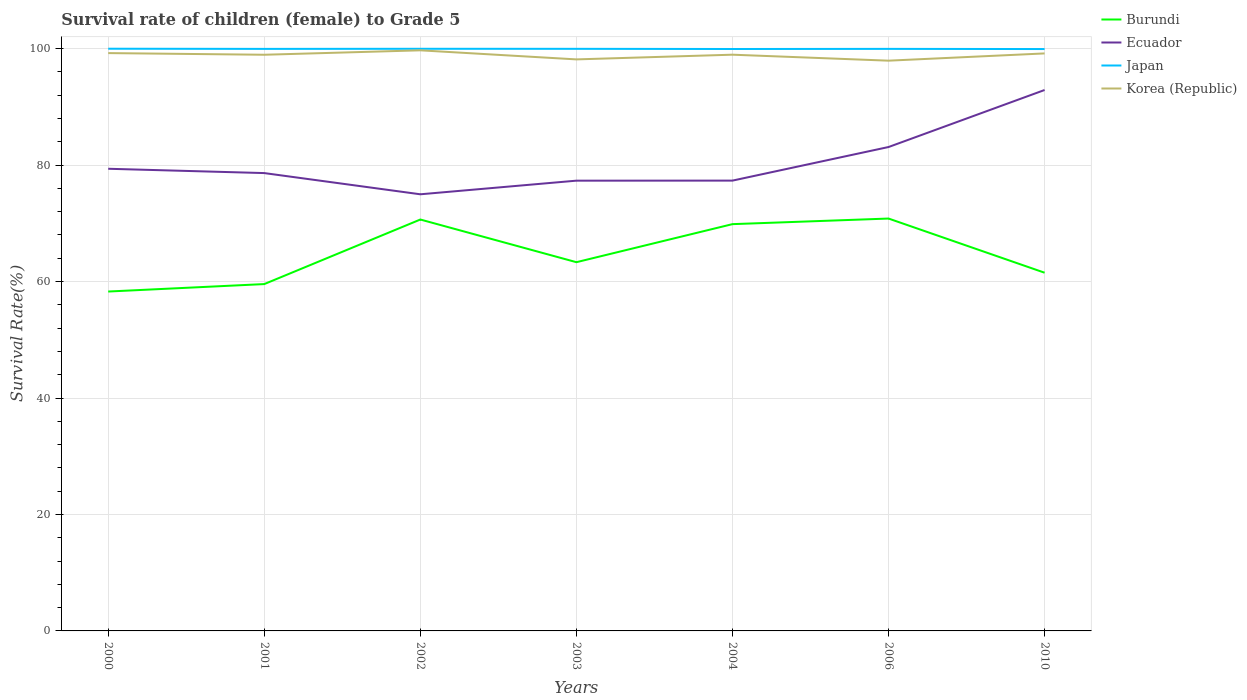How many different coloured lines are there?
Your answer should be very brief. 4. Does the line corresponding to Korea (Republic) intersect with the line corresponding to Ecuador?
Offer a terse response. No. Is the number of lines equal to the number of legend labels?
Offer a very short reply. Yes. Across all years, what is the maximum survival rate of female children to grade 5 in Burundi?
Offer a very short reply. 58.29. In which year was the survival rate of female children to grade 5 in Burundi maximum?
Offer a very short reply. 2000. What is the total survival rate of female children to grade 5 in Burundi in the graph?
Offer a very short reply. -3.23. What is the difference between the highest and the second highest survival rate of female children to grade 5 in Burundi?
Ensure brevity in your answer.  12.53. How many lines are there?
Provide a short and direct response. 4. What is the difference between two consecutive major ticks on the Y-axis?
Give a very brief answer. 20. Are the values on the major ticks of Y-axis written in scientific E-notation?
Offer a very short reply. No. Does the graph contain any zero values?
Provide a succinct answer. No. Does the graph contain grids?
Your answer should be very brief. Yes. What is the title of the graph?
Keep it short and to the point. Survival rate of children (female) to Grade 5. Does "Kyrgyz Republic" appear as one of the legend labels in the graph?
Your answer should be compact. No. What is the label or title of the Y-axis?
Offer a terse response. Survival Rate(%). What is the Survival Rate(%) of Burundi in 2000?
Provide a short and direct response. 58.29. What is the Survival Rate(%) in Ecuador in 2000?
Your answer should be very brief. 79.37. What is the Survival Rate(%) in Japan in 2000?
Make the answer very short. 99.99. What is the Survival Rate(%) of Korea (Republic) in 2000?
Offer a terse response. 99.24. What is the Survival Rate(%) in Burundi in 2001?
Make the answer very short. 59.57. What is the Survival Rate(%) in Ecuador in 2001?
Your response must be concise. 78.63. What is the Survival Rate(%) in Japan in 2001?
Provide a succinct answer. 99.96. What is the Survival Rate(%) of Korea (Republic) in 2001?
Provide a short and direct response. 98.96. What is the Survival Rate(%) in Burundi in 2002?
Offer a terse response. 70.66. What is the Survival Rate(%) in Ecuador in 2002?
Ensure brevity in your answer.  74.99. What is the Survival Rate(%) of Japan in 2002?
Make the answer very short. 99.98. What is the Survival Rate(%) of Korea (Republic) in 2002?
Offer a very short reply. 99.71. What is the Survival Rate(%) in Burundi in 2003?
Offer a terse response. 63.33. What is the Survival Rate(%) in Ecuador in 2003?
Provide a succinct answer. 77.33. What is the Survival Rate(%) in Japan in 2003?
Your response must be concise. 99.97. What is the Survival Rate(%) of Korea (Republic) in 2003?
Provide a succinct answer. 98.16. What is the Survival Rate(%) in Burundi in 2004?
Your answer should be very brief. 69.86. What is the Survival Rate(%) in Ecuador in 2004?
Your response must be concise. 77.34. What is the Survival Rate(%) of Japan in 2004?
Provide a short and direct response. 99.94. What is the Survival Rate(%) of Korea (Republic) in 2004?
Your answer should be compact. 98.97. What is the Survival Rate(%) in Burundi in 2006?
Provide a succinct answer. 70.82. What is the Survival Rate(%) in Ecuador in 2006?
Provide a succinct answer. 83.11. What is the Survival Rate(%) in Japan in 2006?
Offer a terse response. 99.97. What is the Survival Rate(%) in Korea (Republic) in 2006?
Provide a succinct answer. 97.94. What is the Survival Rate(%) in Burundi in 2010?
Make the answer very short. 61.52. What is the Survival Rate(%) in Ecuador in 2010?
Your answer should be compact. 92.9. What is the Survival Rate(%) in Japan in 2010?
Offer a very short reply. 99.94. What is the Survival Rate(%) in Korea (Republic) in 2010?
Give a very brief answer. 99.18. Across all years, what is the maximum Survival Rate(%) of Burundi?
Your answer should be very brief. 70.82. Across all years, what is the maximum Survival Rate(%) in Ecuador?
Your answer should be very brief. 92.9. Across all years, what is the maximum Survival Rate(%) in Japan?
Offer a terse response. 99.99. Across all years, what is the maximum Survival Rate(%) of Korea (Republic)?
Offer a very short reply. 99.71. Across all years, what is the minimum Survival Rate(%) of Burundi?
Ensure brevity in your answer.  58.29. Across all years, what is the minimum Survival Rate(%) of Ecuador?
Offer a very short reply. 74.99. Across all years, what is the minimum Survival Rate(%) of Japan?
Provide a succinct answer. 99.94. Across all years, what is the minimum Survival Rate(%) of Korea (Republic)?
Keep it short and to the point. 97.94. What is the total Survival Rate(%) in Burundi in the graph?
Your answer should be compact. 454.05. What is the total Survival Rate(%) of Ecuador in the graph?
Make the answer very short. 563.68. What is the total Survival Rate(%) of Japan in the graph?
Provide a succinct answer. 699.75. What is the total Survival Rate(%) of Korea (Republic) in the graph?
Your answer should be compact. 692.16. What is the difference between the Survival Rate(%) in Burundi in 2000 and that in 2001?
Provide a short and direct response. -1.28. What is the difference between the Survival Rate(%) in Ecuador in 2000 and that in 2001?
Give a very brief answer. 0.74. What is the difference between the Survival Rate(%) of Japan in 2000 and that in 2001?
Offer a very short reply. 0.03. What is the difference between the Survival Rate(%) of Korea (Republic) in 2000 and that in 2001?
Your response must be concise. 0.28. What is the difference between the Survival Rate(%) in Burundi in 2000 and that in 2002?
Your answer should be very brief. -12.37. What is the difference between the Survival Rate(%) of Ecuador in 2000 and that in 2002?
Make the answer very short. 4.38. What is the difference between the Survival Rate(%) in Japan in 2000 and that in 2002?
Your answer should be very brief. 0.01. What is the difference between the Survival Rate(%) in Korea (Republic) in 2000 and that in 2002?
Give a very brief answer. -0.47. What is the difference between the Survival Rate(%) in Burundi in 2000 and that in 2003?
Offer a terse response. -5.04. What is the difference between the Survival Rate(%) of Ecuador in 2000 and that in 2003?
Offer a terse response. 2.04. What is the difference between the Survival Rate(%) of Japan in 2000 and that in 2003?
Ensure brevity in your answer.  0.02. What is the difference between the Survival Rate(%) in Korea (Republic) in 2000 and that in 2003?
Offer a terse response. 1.08. What is the difference between the Survival Rate(%) of Burundi in 2000 and that in 2004?
Offer a very short reply. -11.57. What is the difference between the Survival Rate(%) in Ecuador in 2000 and that in 2004?
Ensure brevity in your answer.  2.03. What is the difference between the Survival Rate(%) of Japan in 2000 and that in 2004?
Your response must be concise. 0.05. What is the difference between the Survival Rate(%) in Korea (Republic) in 2000 and that in 2004?
Provide a short and direct response. 0.27. What is the difference between the Survival Rate(%) of Burundi in 2000 and that in 2006?
Give a very brief answer. -12.53. What is the difference between the Survival Rate(%) in Ecuador in 2000 and that in 2006?
Offer a terse response. -3.73. What is the difference between the Survival Rate(%) of Japan in 2000 and that in 2006?
Provide a succinct answer. 0.03. What is the difference between the Survival Rate(%) of Korea (Republic) in 2000 and that in 2006?
Ensure brevity in your answer.  1.3. What is the difference between the Survival Rate(%) in Burundi in 2000 and that in 2010?
Ensure brevity in your answer.  -3.23. What is the difference between the Survival Rate(%) of Ecuador in 2000 and that in 2010?
Keep it short and to the point. -13.53. What is the difference between the Survival Rate(%) in Japan in 2000 and that in 2010?
Offer a very short reply. 0.06. What is the difference between the Survival Rate(%) in Korea (Republic) in 2000 and that in 2010?
Ensure brevity in your answer.  0.06. What is the difference between the Survival Rate(%) in Burundi in 2001 and that in 2002?
Your answer should be compact. -11.09. What is the difference between the Survival Rate(%) in Ecuador in 2001 and that in 2002?
Provide a succinct answer. 3.64. What is the difference between the Survival Rate(%) in Japan in 2001 and that in 2002?
Your answer should be compact. -0.02. What is the difference between the Survival Rate(%) in Korea (Republic) in 2001 and that in 2002?
Ensure brevity in your answer.  -0.76. What is the difference between the Survival Rate(%) of Burundi in 2001 and that in 2003?
Make the answer very short. -3.76. What is the difference between the Survival Rate(%) in Ecuador in 2001 and that in 2003?
Offer a terse response. 1.3. What is the difference between the Survival Rate(%) in Japan in 2001 and that in 2003?
Offer a very short reply. -0.01. What is the difference between the Survival Rate(%) in Korea (Republic) in 2001 and that in 2003?
Give a very brief answer. 0.8. What is the difference between the Survival Rate(%) in Burundi in 2001 and that in 2004?
Your response must be concise. -10.29. What is the difference between the Survival Rate(%) in Ecuador in 2001 and that in 2004?
Offer a terse response. 1.29. What is the difference between the Survival Rate(%) of Japan in 2001 and that in 2004?
Provide a succinct answer. 0.02. What is the difference between the Survival Rate(%) of Korea (Republic) in 2001 and that in 2004?
Your response must be concise. -0.01. What is the difference between the Survival Rate(%) of Burundi in 2001 and that in 2006?
Make the answer very short. -11.25. What is the difference between the Survival Rate(%) of Ecuador in 2001 and that in 2006?
Your answer should be very brief. -4.47. What is the difference between the Survival Rate(%) of Japan in 2001 and that in 2006?
Your answer should be compact. -0. What is the difference between the Survival Rate(%) of Korea (Republic) in 2001 and that in 2006?
Offer a very short reply. 1.02. What is the difference between the Survival Rate(%) in Burundi in 2001 and that in 2010?
Keep it short and to the point. -1.95. What is the difference between the Survival Rate(%) of Ecuador in 2001 and that in 2010?
Your answer should be compact. -14.27. What is the difference between the Survival Rate(%) in Japan in 2001 and that in 2010?
Keep it short and to the point. 0.03. What is the difference between the Survival Rate(%) in Korea (Republic) in 2001 and that in 2010?
Keep it short and to the point. -0.23. What is the difference between the Survival Rate(%) of Burundi in 2002 and that in 2003?
Offer a terse response. 7.33. What is the difference between the Survival Rate(%) of Ecuador in 2002 and that in 2003?
Offer a terse response. -2.34. What is the difference between the Survival Rate(%) in Japan in 2002 and that in 2003?
Provide a short and direct response. 0.01. What is the difference between the Survival Rate(%) in Korea (Republic) in 2002 and that in 2003?
Your answer should be compact. 1.56. What is the difference between the Survival Rate(%) in Burundi in 2002 and that in 2004?
Keep it short and to the point. 0.79. What is the difference between the Survival Rate(%) in Ecuador in 2002 and that in 2004?
Your response must be concise. -2.35. What is the difference between the Survival Rate(%) in Japan in 2002 and that in 2004?
Your answer should be compact. 0.04. What is the difference between the Survival Rate(%) of Korea (Republic) in 2002 and that in 2004?
Give a very brief answer. 0.75. What is the difference between the Survival Rate(%) of Burundi in 2002 and that in 2006?
Make the answer very short. -0.17. What is the difference between the Survival Rate(%) of Ecuador in 2002 and that in 2006?
Offer a very short reply. -8.12. What is the difference between the Survival Rate(%) in Japan in 2002 and that in 2006?
Make the answer very short. 0.01. What is the difference between the Survival Rate(%) of Korea (Republic) in 2002 and that in 2006?
Your answer should be compact. 1.78. What is the difference between the Survival Rate(%) of Burundi in 2002 and that in 2010?
Ensure brevity in your answer.  9.14. What is the difference between the Survival Rate(%) of Ecuador in 2002 and that in 2010?
Your answer should be very brief. -17.91. What is the difference between the Survival Rate(%) of Japan in 2002 and that in 2010?
Your response must be concise. 0.04. What is the difference between the Survival Rate(%) of Korea (Republic) in 2002 and that in 2010?
Offer a terse response. 0.53. What is the difference between the Survival Rate(%) of Burundi in 2003 and that in 2004?
Give a very brief answer. -6.54. What is the difference between the Survival Rate(%) in Ecuador in 2003 and that in 2004?
Keep it short and to the point. -0.01. What is the difference between the Survival Rate(%) in Japan in 2003 and that in 2004?
Your response must be concise. 0.03. What is the difference between the Survival Rate(%) in Korea (Republic) in 2003 and that in 2004?
Make the answer very short. -0.81. What is the difference between the Survival Rate(%) of Burundi in 2003 and that in 2006?
Provide a short and direct response. -7.5. What is the difference between the Survival Rate(%) in Ecuador in 2003 and that in 2006?
Provide a short and direct response. -5.78. What is the difference between the Survival Rate(%) in Japan in 2003 and that in 2006?
Give a very brief answer. 0.01. What is the difference between the Survival Rate(%) of Korea (Republic) in 2003 and that in 2006?
Ensure brevity in your answer.  0.22. What is the difference between the Survival Rate(%) of Burundi in 2003 and that in 2010?
Keep it short and to the point. 1.81. What is the difference between the Survival Rate(%) in Ecuador in 2003 and that in 2010?
Offer a terse response. -15.57. What is the difference between the Survival Rate(%) of Japan in 2003 and that in 2010?
Your answer should be very brief. 0.04. What is the difference between the Survival Rate(%) in Korea (Republic) in 2003 and that in 2010?
Your answer should be very brief. -1.02. What is the difference between the Survival Rate(%) of Burundi in 2004 and that in 2006?
Your answer should be compact. -0.96. What is the difference between the Survival Rate(%) of Ecuador in 2004 and that in 2006?
Ensure brevity in your answer.  -5.77. What is the difference between the Survival Rate(%) in Japan in 2004 and that in 2006?
Make the answer very short. -0.02. What is the difference between the Survival Rate(%) of Korea (Republic) in 2004 and that in 2006?
Your response must be concise. 1.03. What is the difference between the Survival Rate(%) in Burundi in 2004 and that in 2010?
Your answer should be compact. 8.34. What is the difference between the Survival Rate(%) in Ecuador in 2004 and that in 2010?
Make the answer very short. -15.56. What is the difference between the Survival Rate(%) of Japan in 2004 and that in 2010?
Make the answer very short. 0.01. What is the difference between the Survival Rate(%) of Korea (Republic) in 2004 and that in 2010?
Your answer should be very brief. -0.22. What is the difference between the Survival Rate(%) of Burundi in 2006 and that in 2010?
Your answer should be very brief. 9.3. What is the difference between the Survival Rate(%) in Ecuador in 2006 and that in 2010?
Provide a succinct answer. -9.8. What is the difference between the Survival Rate(%) in Japan in 2006 and that in 2010?
Ensure brevity in your answer.  0.03. What is the difference between the Survival Rate(%) of Korea (Republic) in 2006 and that in 2010?
Give a very brief answer. -1.24. What is the difference between the Survival Rate(%) in Burundi in 2000 and the Survival Rate(%) in Ecuador in 2001?
Provide a short and direct response. -20.34. What is the difference between the Survival Rate(%) of Burundi in 2000 and the Survival Rate(%) of Japan in 2001?
Your answer should be compact. -41.67. What is the difference between the Survival Rate(%) of Burundi in 2000 and the Survival Rate(%) of Korea (Republic) in 2001?
Ensure brevity in your answer.  -40.67. What is the difference between the Survival Rate(%) in Ecuador in 2000 and the Survival Rate(%) in Japan in 2001?
Give a very brief answer. -20.59. What is the difference between the Survival Rate(%) in Ecuador in 2000 and the Survival Rate(%) in Korea (Republic) in 2001?
Provide a succinct answer. -19.58. What is the difference between the Survival Rate(%) of Japan in 2000 and the Survival Rate(%) of Korea (Republic) in 2001?
Offer a terse response. 1.04. What is the difference between the Survival Rate(%) of Burundi in 2000 and the Survival Rate(%) of Ecuador in 2002?
Provide a succinct answer. -16.7. What is the difference between the Survival Rate(%) in Burundi in 2000 and the Survival Rate(%) in Japan in 2002?
Your response must be concise. -41.69. What is the difference between the Survival Rate(%) of Burundi in 2000 and the Survival Rate(%) of Korea (Republic) in 2002?
Offer a very short reply. -41.43. What is the difference between the Survival Rate(%) of Ecuador in 2000 and the Survival Rate(%) of Japan in 2002?
Ensure brevity in your answer.  -20.61. What is the difference between the Survival Rate(%) of Ecuador in 2000 and the Survival Rate(%) of Korea (Republic) in 2002?
Offer a very short reply. -20.34. What is the difference between the Survival Rate(%) in Japan in 2000 and the Survival Rate(%) in Korea (Republic) in 2002?
Give a very brief answer. 0.28. What is the difference between the Survival Rate(%) of Burundi in 2000 and the Survival Rate(%) of Ecuador in 2003?
Provide a short and direct response. -19.04. What is the difference between the Survival Rate(%) of Burundi in 2000 and the Survival Rate(%) of Japan in 2003?
Provide a short and direct response. -41.68. What is the difference between the Survival Rate(%) in Burundi in 2000 and the Survival Rate(%) in Korea (Republic) in 2003?
Ensure brevity in your answer.  -39.87. What is the difference between the Survival Rate(%) of Ecuador in 2000 and the Survival Rate(%) of Japan in 2003?
Offer a terse response. -20.6. What is the difference between the Survival Rate(%) in Ecuador in 2000 and the Survival Rate(%) in Korea (Republic) in 2003?
Your answer should be compact. -18.79. What is the difference between the Survival Rate(%) in Japan in 2000 and the Survival Rate(%) in Korea (Republic) in 2003?
Your answer should be compact. 1.83. What is the difference between the Survival Rate(%) of Burundi in 2000 and the Survival Rate(%) of Ecuador in 2004?
Your response must be concise. -19.05. What is the difference between the Survival Rate(%) of Burundi in 2000 and the Survival Rate(%) of Japan in 2004?
Give a very brief answer. -41.65. What is the difference between the Survival Rate(%) in Burundi in 2000 and the Survival Rate(%) in Korea (Republic) in 2004?
Make the answer very short. -40.68. What is the difference between the Survival Rate(%) of Ecuador in 2000 and the Survival Rate(%) of Japan in 2004?
Your answer should be compact. -20.57. What is the difference between the Survival Rate(%) in Ecuador in 2000 and the Survival Rate(%) in Korea (Republic) in 2004?
Offer a terse response. -19.59. What is the difference between the Survival Rate(%) of Japan in 2000 and the Survival Rate(%) of Korea (Republic) in 2004?
Provide a succinct answer. 1.03. What is the difference between the Survival Rate(%) in Burundi in 2000 and the Survival Rate(%) in Ecuador in 2006?
Give a very brief answer. -24.82. What is the difference between the Survival Rate(%) of Burundi in 2000 and the Survival Rate(%) of Japan in 2006?
Ensure brevity in your answer.  -41.68. What is the difference between the Survival Rate(%) in Burundi in 2000 and the Survival Rate(%) in Korea (Republic) in 2006?
Keep it short and to the point. -39.65. What is the difference between the Survival Rate(%) in Ecuador in 2000 and the Survival Rate(%) in Japan in 2006?
Ensure brevity in your answer.  -20.59. What is the difference between the Survival Rate(%) in Ecuador in 2000 and the Survival Rate(%) in Korea (Republic) in 2006?
Offer a terse response. -18.57. What is the difference between the Survival Rate(%) of Japan in 2000 and the Survival Rate(%) of Korea (Republic) in 2006?
Keep it short and to the point. 2.05. What is the difference between the Survival Rate(%) of Burundi in 2000 and the Survival Rate(%) of Ecuador in 2010?
Offer a very short reply. -34.61. What is the difference between the Survival Rate(%) of Burundi in 2000 and the Survival Rate(%) of Japan in 2010?
Your response must be concise. -41.65. What is the difference between the Survival Rate(%) in Burundi in 2000 and the Survival Rate(%) in Korea (Republic) in 2010?
Keep it short and to the point. -40.89. What is the difference between the Survival Rate(%) of Ecuador in 2000 and the Survival Rate(%) of Japan in 2010?
Your answer should be compact. -20.56. What is the difference between the Survival Rate(%) in Ecuador in 2000 and the Survival Rate(%) in Korea (Republic) in 2010?
Provide a succinct answer. -19.81. What is the difference between the Survival Rate(%) in Japan in 2000 and the Survival Rate(%) in Korea (Republic) in 2010?
Your response must be concise. 0.81. What is the difference between the Survival Rate(%) of Burundi in 2001 and the Survival Rate(%) of Ecuador in 2002?
Your answer should be compact. -15.42. What is the difference between the Survival Rate(%) of Burundi in 2001 and the Survival Rate(%) of Japan in 2002?
Ensure brevity in your answer.  -40.41. What is the difference between the Survival Rate(%) in Burundi in 2001 and the Survival Rate(%) in Korea (Republic) in 2002?
Offer a terse response. -40.14. What is the difference between the Survival Rate(%) in Ecuador in 2001 and the Survival Rate(%) in Japan in 2002?
Provide a short and direct response. -21.35. What is the difference between the Survival Rate(%) in Ecuador in 2001 and the Survival Rate(%) in Korea (Republic) in 2002?
Your answer should be very brief. -21.08. What is the difference between the Survival Rate(%) in Japan in 2001 and the Survival Rate(%) in Korea (Republic) in 2002?
Give a very brief answer. 0.25. What is the difference between the Survival Rate(%) in Burundi in 2001 and the Survival Rate(%) in Ecuador in 2003?
Offer a very short reply. -17.76. What is the difference between the Survival Rate(%) in Burundi in 2001 and the Survival Rate(%) in Japan in 2003?
Your answer should be compact. -40.4. What is the difference between the Survival Rate(%) in Burundi in 2001 and the Survival Rate(%) in Korea (Republic) in 2003?
Offer a terse response. -38.59. What is the difference between the Survival Rate(%) in Ecuador in 2001 and the Survival Rate(%) in Japan in 2003?
Give a very brief answer. -21.34. What is the difference between the Survival Rate(%) of Ecuador in 2001 and the Survival Rate(%) of Korea (Republic) in 2003?
Your answer should be compact. -19.53. What is the difference between the Survival Rate(%) of Japan in 2001 and the Survival Rate(%) of Korea (Republic) in 2003?
Provide a succinct answer. 1.8. What is the difference between the Survival Rate(%) in Burundi in 2001 and the Survival Rate(%) in Ecuador in 2004?
Your answer should be compact. -17.77. What is the difference between the Survival Rate(%) in Burundi in 2001 and the Survival Rate(%) in Japan in 2004?
Offer a terse response. -40.37. What is the difference between the Survival Rate(%) of Burundi in 2001 and the Survival Rate(%) of Korea (Republic) in 2004?
Your answer should be very brief. -39.4. What is the difference between the Survival Rate(%) in Ecuador in 2001 and the Survival Rate(%) in Japan in 2004?
Ensure brevity in your answer.  -21.31. What is the difference between the Survival Rate(%) in Ecuador in 2001 and the Survival Rate(%) in Korea (Republic) in 2004?
Keep it short and to the point. -20.33. What is the difference between the Survival Rate(%) in Japan in 2001 and the Survival Rate(%) in Korea (Republic) in 2004?
Keep it short and to the point. 1. What is the difference between the Survival Rate(%) in Burundi in 2001 and the Survival Rate(%) in Ecuador in 2006?
Provide a succinct answer. -23.54. What is the difference between the Survival Rate(%) of Burundi in 2001 and the Survival Rate(%) of Japan in 2006?
Your response must be concise. -40.4. What is the difference between the Survival Rate(%) in Burundi in 2001 and the Survival Rate(%) in Korea (Republic) in 2006?
Provide a succinct answer. -38.37. What is the difference between the Survival Rate(%) in Ecuador in 2001 and the Survival Rate(%) in Japan in 2006?
Your response must be concise. -21.33. What is the difference between the Survival Rate(%) in Ecuador in 2001 and the Survival Rate(%) in Korea (Republic) in 2006?
Your response must be concise. -19.31. What is the difference between the Survival Rate(%) of Japan in 2001 and the Survival Rate(%) of Korea (Republic) in 2006?
Give a very brief answer. 2.02. What is the difference between the Survival Rate(%) of Burundi in 2001 and the Survival Rate(%) of Ecuador in 2010?
Make the answer very short. -33.33. What is the difference between the Survival Rate(%) of Burundi in 2001 and the Survival Rate(%) of Japan in 2010?
Ensure brevity in your answer.  -40.37. What is the difference between the Survival Rate(%) of Burundi in 2001 and the Survival Rate(%) of Korea (Republic) in 2010?
Offer a terse response. -39.61. What is the difference between the Survival Rate(%) of Ecuador in 2001 and the Survival Rate(%) of Japan in 2010?
Make the answer very short. -21.3. What is the difference between the Survival Rate(%) of Ecuador in 2001 and the Survival Rate(%) of Korea (Republic) in 2010?
Your response must be concise. -20.55. What is the difference between the Survival Rate(%) of Japan in 2001 and the Survival Rate(%) of Korea (Republic) in 2010?
Make the answer very short. 0.78. What is the difference between the Survival Rate(%) in Burundi in 2002 and the Survival Rate(%) in Ecuador in 2003?
Make the answer very short. -6.67. What is the difference between the Survival Rate(%) in Burundi in 2002 and the Survival Rate(%) in Japan in 2003?
Give a very brief answer. -29.32. What is the difference between the Survival Rate(%) in Burundi in 2002 and the Survival Rate(%) in Korea (Republic) in 2003?
Offer a terse response. -27.5. What is the difference between the Survival Rate(%) in Ecuador in 2002 and the Survival Rate(%) in Japan in 2003?
Offer a terse response. -24.98. What is the difference between the Survival Rate(%) in Ecuador in 2002 and the Survival Rate(%) in Korea (Republic) in 2003?
Offer a very short reply. -23.17. What is the difference between the Survival Rate(%) of Japan in 2002 and the Survival Rate(%) of Korea (Republic) in 2003?
Offer a very short reply. 1.82. What is the difference between the Survival Rate(%) in Burundi in 2002 and the Survival Rate(%) in Ecuador in 2004?
Make the answer very short. -6.68. What is the difference between the Survival Rate(%) of Burundi in 2002 and the Survival Rate(%) of Japan in 2004?
Your answer should be compact. -29.29. What is the difference between the Survival Rate(%) in Burundi in 2002 and the Survival Rate(%) in Korea (Republic) in 2004?
Provide a succinct answer. -28.31. What is the difference between the Survival Rate(%) of Ecuador in 2002 and the Survival Rate(%) of Japan in 2004?
Give a very brief answer. -24.95. What is the difference between the Survival Rate(%) in Ecuador in 2002 and the Survival Rate(%) in Korea (Republic) in 2004?
Provide a succinct answer. -23.98. What is the difference between the Survival Rate(%) of Burundi in 2002 and the Survival Rate(%) of Ecuador in 2006?
Give a very brief answer. -12.45. What is the difference between the Survival Rate(%) of Burundi in 2002 and the Survival Rate(%) of Japan in 2006?
Provide a short and direct response. -29.31. What is the difference between the Survival Rate(%) in Burundi in 2002 and the Survival Rate(%) in Korea (Republic) in 2006?
Offer a terse response. -27.28. What is the difference between the Survival Rate(%) of Ecuador in 2002 and the Survival Rate(%) of Japan in 2006?
Provide a succinct answer. -24.97. What is the difference between the Survival Rate(%) in Ecuador in 2002 and the Survival Rate(%) in Korea (Republic) in 2006?
Give a very brief answer. -22.95. What is the difference between the Survival Rate(%) in Japan in 2002 and the Survival Rate(%) in Korea (Republic) in 2006?
Keep it short and to the point. 2.04. What is the difference between the Survival Rate(%) in Burundi in 2002 and the Survival Rate(%) in Ecuador in 2010?
Give a very brief answer. -22.25. What is the difference between the Survival Rate(%) of Burundi in 2002 and the Survival Rate(%) of Japan in 2010?
Offer a very short reply. -29.28. What is the difference between the Survival Rate(%) in Burundi in 2002 and the Survival Rate(%) in Korea (Republic) in 2010?
Your answer should be very brief. -28.53. What is the difference between the Survival Rate(%) in Ecuador in 2002 and the Survival Rate(%) in Japan in 2010?
Offer a very short reply. -24.95. What is the difference between the Survival Rate(%) in Ecuador in 2002 and the Survival Rate(%) in Korea (Republic) in 2010?
Offer a terse response. -24.19. What is the difference between the Survival Rate(%) in Japan in 2002 and the Survival Rate(%) in Korea (Republic) in 2010?
Make the answer very short. 0.8. What is the difference between the Survival Rate(%) in Burundi in 2003 and the Survival Rate(%) in Ecuador in 2004?
Make the answer very short. -14.01. What is the difference between the Survival Rate(%) of Burundi in 2003 and the Survival Rate(%) of Japan in 2004?
Your answer should be compact. -36.61. What is the difference between the Survival Rate(%) in Burundi in 2003 and the Survival Rate(%) in Korea (Republic) in 2004?
Provide a succinct answer. -35.64. What is the difference between the Survival Rate(%) in Ecuador in 2003 and the Survival Rate(%) in Japan in 2004?
Your response must be concise. -22.61. What is the difference between the Survival Rate(%) in Ecuador in 2003 and the Survival Rate(%) in Korea (Republic) in 2004?
Your response must be concise. -21.64. What is the difference between the Survival Rate(%) in Japan in 2003 and the Survival Rate(%) in Korea (Republic) in 2004?
Offer a terse response. 1.01. What is the difference between the Survival Rate(%) of Burundi in 2003 and the Survival Rate(%) of Ecuador in 2006?
Offer a terse response. -19.78. What is the difference between the Survival Rate(%) in Burundi in 2003 and the Survival Rate(%) in Japan in 2006?
Provide a short and direct response. -36.64. What is the difference between the Survival Rate(%) of Burundi in 2003 and the Survival Rate(%) of Korea (Republic) in 2006?
Offer a very short reply. -34.61. What is the difference between the Survival Rate(%) in Ecuador in 2003 and the Survival Rate(%) in Japan in 2006?
Provide a short and direct response. -22.64. What is the difference between the Survival Rate(%) in Ecuador in 2003 and the Survival Rate(%) in Korea (Republic) in 2006?
Your answer should be very brief. -20.61. What is the difference between the Survival Rate(%) in Japan in 2003 and the Survival Rate(%) in Korea (Republic) in 2006?
Keep it short and to the point. 2.03. What is the difference between the Survival Rate(%) in Burundi in 2003 and the Survival Rate(%) in Ecuador in 2010?
Make the answer very short. -29.57. What is the difference between the Survival Rate(%) of Burundi in 2003 and the Survival Rate(%) of Japan in 2010?
Make the answer very short. -36.61. What is the difference between the Survival Rate(%) of Burundi in 2003 and the Survival Rate(%) of Korea (Republic) in 2010?
Ensure brevity in your answer.  -35.86. What is the difference between the Survival Rate(%) of Ecuador in 2003 and the Survival Rate(%) of Japan in 2010?
Your response must be concise. -22.61. What is the difference between the Survival Rate(%) in Ecuador in 2003 and the Survival Rate(%) in Korea (Republic) in 2010?
Ensure brevity in your answer.  -21.85. What is the difference between the Survival Rate(%) in Japan in 2003 and the Survival Rate(%) in Korea (Republic) in 2010?
Offer a terse response. 0.79. What is the difference between the Survival Rate(%) of Burundi in 2004 and the Survival Rate(%) of Ecuador in 2006?
Offer a terse response. -13.24. What is the difference between the Survival Rate(%) of Burundi in 2004 and the Survival Rate(%) of Japan in 2006?
Make the answer very short. -30.1. What is the difference between the Survival Rate(%) of Burundi in 2004 and the Survival Rate(%) of Korea (Republic) in 2006?
Your answer should be very brief. -28.08. What is the difference between the Survival Rate(%) in Ecuador in 2004 and the Survival Rate(%) in Japan in 2006?
Keep it short and to the point. -22.63. What is the difference between the Survival Rate(%) of Ecuador in 2004 and the Survival Rate(%) of Korea (Republic) in 2006?
Provide a short and direct response. -20.6. What is the difference between the Survival Rate(%) of Japan in 2004 and the Survival Rate(%) of Korea (Republic) in 2006?
Provide a succinct answer. 2. What is the difference between the Survival Rate(%) in Burundi in 2004 and the Survival Rate(%) in Ecuador in 2010?
Make the answer very short. -23.04. What is the difference between the Survival Rate(%) in Burundi in 2004 and the Survival Rate(%) in Japan in 2010?
Offer a very short reply. -30.07. What is the difference between the Survival Rate(%) of Burundi in 2004 and the Survival Rate(%) of Korea (Republic) in 2010?
Make the answer very short. -29.32. What is the difference between the Survival Rate(%) of Ecuador in 2004 and the Survival Rate(%) of Japan in 2010?
Keep it short and to the point. -22.6. What is the difference between the Survival Rate(%) in Ecuador in 2004 and the Survival Rate(%) in Korea (Republic) in 2010?
Provide a succinct answer. -21.84. What is the difference between the Survival Rate(%) in Japan in 2004 and the Survival Rate(%) in Korea (Republic) in 2010?
Provide a succinct answer. 0.76. What is the difference between the Survival Rate(%) in Burundi in 2006 and the Survival Rate(%) in Ecuador in 2010?
Your response must be concise. -22.08. What is the difference between the Survival Rate(%) of Burundi in 2006 and the Survival Rate(%) of Japan in 2010?
Keep it short and to the point. -29.11. What is the difference between the Survival Rate(%) of Burundi in 2006 and the Survival Rate(%) of Korea (Republic) in 2010?
Your answer should be compact. -28.36. What is the difference between the Survival Rate(%) in Ecuador in 2006 and the Survival Rate(%) in Japan in 2010?
Your answer should be very brief. -16.83. What is the difference between the Survival Rate(%) in Ecuador in 2006 and the Survival Rate(%) in Korea (Republic) in 2010?
Give a very brief answer. -16.08. What is the difference between the Survival Rate(%) in Japan in 2006 and the Survival Rate(%) in Korea (Republic) in 2010?
Make the answer very short. 0.78. What is the average Survival Rate(%) of Burundi per year?
Provide a short and direct response. 64.86. What is the average Survival Rate(%) of Ecuador per year?
Keep it short and to the point. 80.53. What is the average Survival Rate(%) of Japan per year?
Provide a short and direct response. 99.96. What is the average Survival Rate(%) in Korea (Republic) per year?
Offer a terse response. 98.88. In the year 2000, what is the difference between the Survival Rate(%) in Burundi and Survival Rate(%) in Ecuador?
Keep it short and to the point. -21.08. In the year 2000, what is the difference between the Survival Rate(%) of Burundi and Survival Rate(%) of Japan?
Offer a terse response. -41.7. In the year 2000, what is the difference between the Survival Rate(%) in Burundi and Survival Rate(%) in Korea (Republic)?
Ensure brevity in your answer.  -40.95. In the year 2000, what is the difference between the Survival Rate(%) in Ecuador and Survival Rate(%) in Japan?
Your answer should be compact. -20.62. In the year 2000, what is the difference between the Survival Rate(%) of Ecuador and Survival Rate(%) of Korea (Republic)?
Your response must be concise. -19.87. In the year 2000, what is the difference between the Survival Rate(%) in Japan and Survival Rate(%) in Korea (Republic)?
Your response must be concise. 0.75. In the year 2001, what is the difference between the Survival Rate(%) in Burundi and Survival Rate(%) in Ecuador?
Provide a short and direct response. -19.06. In the year 2001, what is the difference between the Survival Rate(%) in Burundi and Survival Rate(%) in Japan?
Provide a short and direct response. -40.39. In the year 2001, what is the difference between the Survival Rate(%) of Burundi and Survival Rate(%) of Korea (Republic)?
Provide a short and direct response. -39.39. In the year 2001, what is the difference between the Survival Rate(%) in Ecuador and Survival Rate(%) in Japan?
Ensure brevity in your answer.  -21.33. In the year 2001, what is the difference between the Survival Rate(%) of Ecuador and Survival Rate(%) of Korea (Republic)?
Ensure brevity in your answer.  -20.32. In the year 2001, what is the difference between the Survival Rate(%) of Japan and Survival Rate(%) of Korea (Republic)?
Ensure brevity in your answer.  1.01. In the year 2002, what is the difference between the Survival Rate(%) in Burundi and Survival Rate(%) in Ecuador?
Ensure brevity in your answer.  -4.33. In the year 2002, what is the difference between the Survival Rate(%) of Burundi and Survival Rate(%) of Japan?
Your response must be concise. -29.32. In the year 2002, what is the difference between the Survival Rate(%) in Burundi and Survival Rate(%) in Korea (Republic)?
Give a very brief answer. -29.06. In the year 2002, what is the difference between the Survival Rate(%) in Ecuador and Survival Rate(%) in Japan?
Provide a short and direct response. -24.99. In the year 2002, what is the difference between the Survival Rate(%) of Ecuador and Survival Rate(%) of Korea (Republic)?
Make the answer very short. -24.72. In the year 2002, what is the difference between the Survival Rate(%) of Japan and Survival Rate(%) of Korea (Republic)?
Provide a succinct answer. 0.27. In the year 2003, what is the difference between the Survival Rate(%) in Burundi and Survival Rate(%) in Ecuador?
Offer a very short reply. -14. In the year 2003, what is the difference between the Survival Rate(%) in Burundi and Survival Rate(%) in Japan?
Offer a very short reply. -36.65. In the year 2003, what is the difference between the Survival Rate(%) in Burundi and Survival Rate(%) in Korea (Republic)?
Your answer should be very brief. -34.83. In the year 2003, what is the difference between the Survival Rate(%) in Ecuador and Survival Rate(%) in Japan?
Keep it short and to the point. -22.64. In the year 2003, what is the difference between the Survival Rate(%) of Ecuador and Survival Rate(%) of Korea (Republic)?
Your response must be concise. -20.83. In the year 2003, what is the difference between the Survival Rate(%) in Japan and Survival Rate(%) in Korea (Republic)?
Keep it short and to the point. 1.81. In the year 2004, what is the difference between the Survival Rate(%) in Burundi and Survival Rate(%) in Ecuador?
Your answer should be compact. -7.48. In the year 2004, what is the difference between the Survival Rate(%) of Burundi and Survival Rate(%) of Japan?
Give a very brief answer. -30.08. In the year 2004, what is the difference between the Survival Rate(%) in Burundi and Survival Rate(%) in Korea (Republic)?
Keep it short and to the point. -29.1. In the year 2004, what is the difference between the Survival Rate(%) in Ecuador and Survival Rate(%) in Japan?
Give a very brief answer. -22.6. In the year 2004, what is the difference between the Survival Rate(%) of Ecuador and Survival Rate(%) of Korea (Republic)?
Make the answer very short. -21.63. In the year 2004, what is the difference between the Survival Rate(%) of Japan and Survival Rate(%) of Korea (Republic)?
Offer a very short reply. 0.98. In the year 2006, what is the difference between the Survival Rate(%) in Burundi and Survival Rate(%) in Ecuador?
Your response must be concise. -12.28. In the year 2006, what is the difference between the Survival Rate(%) in Burundi and Survival Rate(%) in Japan?
Offer a very short reply. -29.14. In the year 2006, what is the difference between the Survival Rate(%) in Burundi and Survival Rate(%) in Korea (Republic)?
Provide a succinct answer. -27.12. In the year 2006, what is the difference between the Survival Rate(%) of Ecuador and Survival Rate(%) of Japan?
Ensure brevity in your answer.  -16.86. In the year 2006, what is the difference between the Survival Rate(%) in Ecuador and Survival Rate(%) in Korea (Republic)?
Your response must be concise. -14.83. In the year 2006, what is the difference between the Survival Rate(%) in Japan and Survival Rate(%) in Korea (Republic)?
Offer a terse response. 2.03. In the year 2010, what is the difference between the Survival Rate(%) of Burundi and Survival Rate(%) of Ecuador?
Make the answer very short. -31.38. In the year 2010, what is the difference between the Survival Rate(%) of Burundi and Survival Rate(%) of Japan?
Give a very brief answer. -38.41. In the year 2010, what is the difference between the Survival Rate(%) of Burundi and Survival Rate(%) of Korea (Republic)?
Provide a succinct answer. -37.66. In the year 2010, what is the difference between the Survival Rate(%) in Ecuador and Survival Rate(%) in Japan?
Keep it short and to the point. -7.03. In the year 2010, what is the difference between the Survival Rate(%) in Ecuador and Survival Rate(%) in Korea (Republic)?
Your response must be concise. -6.28. In the year 2010, what is the difference between the Survival Rate(%) of Japan and Survival Rate(%) of Korea (Republic)?
Make the answer very short. 0.75. What is the ratio of the Survival Rate(%) of Burundi in 2000 to that in 2001?
Ensure brevity in your answer.  0.98. What is the ratio of the Survival Rate(%) of Ecuador in 2000 to that in 2001?
Your answer should be very brief. 1.01. What is the ratio of the Survival Rate(%) in Japan in 2000 to that in 2001?
Keep it short and to the point. 1. What is the ratio of the Survival Rate(%) in Korea (Republic) in 2000 to that in 2001?
Make the answer very short. 1. What is the ratio of the Survival Rate(%) in Burundi in 2000 to that in 2002?
Offer a very short reply. 0.82. What is the ratio of the Survival Rate(%) of Ecuador in 2000 to that in 2002?
Ensure brevity in your answer.  1.06. What is the ratio of the Survival Rate(%) of Japan in 2000 to that in 2002?
Your answer should be very brief. 1. What is the ratio of the Survival Rate(%) in Korea (Republic) in 2000 to that in 2002?
Your answer should be compact. 1. What is the ratio of the Survival Rate(%) of Burundi in 2000 to that in 2003?
Your response must be concise. 0.92. What is the ratio of the Survival Rate(%) in Ecuador in 2000 to that in 2003?
Offer a very short reply. 1.03. What is the ratio of the Survival Rate(%) in Japan in 2000 to that in 2003?
Offer a very short reply. 1. What is the ratio of the Survival Rate(%) of Korea (Republic) in 2000 to that in 2003?
Provide a succinct answer. 1.01. What is the ratio of the Survival Rate(%) in Burundi in 2000 to that in 2004?
Ensure brevity in your answer.  0.83. What is the ratio of the Survival Rate(%) of Ecuador in 2000 to that in 2004?
Your response must be concise. 1.03. What is the ratio of the Survival Rate(%) in Korea (Republic) in 2000 to that in 2004?
Provide a succinct answer. 1. What is the ratio of the Survival Rate(%) in Burundi in 2000 to that in 2006?
Provide a short and direct response. 0.82. What is the ratio of the Survival Rate(%) in Ecuador in 2000 to that in 2006?
Offer a very short reply. 0.96. What is the ratio of the Survival Rate(%) in Korea (Republic) in 2000 to that in 2006?
Keep it short and to the point. 1.01. What is the ratio of the Survival Rate(%) of Burundi in 2000 to that in 2010?
Provide a short and direct response. 0.95. What is the ratio of the Survival Rate(%) in Ecuador in 2000 to that in 2010?
Your answer should be compact. 0.85. What is the ratio of the Survival Rate(%) of Japan in 2000 to that in 2010?
Offer a very short reply. 1. What is the ratio of the Survival Rate(%) in Burundi in 2001 to that in 2002?
Offer a terse response. 0.84. What is the ratio of the Survival Rate(%) of Ecuador in 2001 to that in 2002?
Your response must be concise. 1.05. What is the ratio of the Survival Rate(%) of Burundi in 2001 to that in 2003?
Give a very brief answer. 0.94. What is the ratio of the Survival Rate(%) of Ecuador in 2001 to that in 2003?
Ensure brevity in your answer.  1.02. What is the ratio of the Survival Rate(%) of Japan in 2001 to that in 2003?
Make the answer very short. 1. What is the ratio of the Survival Rate(%) in Burundi in 2001 to that in 2004?
Your answer should be very brief. 0.85. What is the ratio of the Survival Rate(%) in Ecuador in 2001 to that in 2004?
Provide a short and direct response. 1.02. What is the ratio of the Survival Rate(%) in Japan in 2001 to that in 2004?
Your answer should be compact. 1. What is the ratio of the Survival Rate(%) of Burundi in 2001 to that in 2006?
Offer a very short reply. 0.84. What is the ratio of the Survival Rate(%) of Ecuador in 2001 to that in 2006?
Ensure brevity in your answer.  0.95. What is the ratio of the Survival Rate(%) in Korea (Republic) in 2001 to that in 2006?
Keep it short and to the point. 1.01. What is the ratio of the Survival Rate(%) in Burundi in 2001 to that in 2010?
Your answer should be compact. 0.97. What is the ratio of the Survival Rate(%) in Ecuador in 2001 to that in 2010?
Your answer should be compact. 0.85. What is the ratio of the Survival Rate(%) of Burundi in 2002 to that in 2003?
Offer a very short reply. 1.12. What is the ratio of the Survival Rate(%) in Ecuador in 2002 to that in 2003?
Give a very brief answer. 0.97. What is the ratio of the Survival Rate(%) in Korea (Republic) in 2002 to that in 2003?
Provide a short and direct response. 1.02. What is the ratio of the Survival Rate(%) in Burundi in 2002 to that in 2004?
Give a very brief answer. 1.01. What is the ratio of the Survival Rate(%) of Ecuador in 2002 to that in 2004?
Keep it short and to the point. 0.97. What is the ratio of the Survival Rate(%) of Korea (Republic) in 2002 to that in 2004?
Keep it short and to the point. 1.01. What is the ratio of the Survival Rate(%) in Burundi in 2002 to that in 2006?
Keep it short and to the point. 1. What is the ratio of the Survival Rate(%) in Ecuador in 2002 to that in 2006?
Keep it short and to the point. 0.9. What is the ratio of the Survival Rate(%) in Korea (Republic) in 2002 to that in 2006?
Give a very brief answer. 1.02. What is the ratio of the Survival Rate(%) of Burundi in 2002 to that in 2010?
Give a very brief answer. 1.15. What is the ratio of the Survival Rate(%) in Ecuador in 2002 to that in 2010?
Make the answer very short. 0.81. What is the ratio of the Survival Rate(%) in Korea (Republic) in 2002 to that in 2010?
Make the answer very short. 1.01. What is the ratio of the Survival Rate(%) of Burundi in 2003 to that in 2004?
Provide a succinct answer. 0.91. What is the ratio of the Survival Rate(%) of Japan in 2003 to that in 2004?
Keep it short and to the point. 1. What is the ratio of the Survival Rate(%) in Burundi in 2003 to that in 2006?
Give a very brief answer. 0.89. What is the ratio of the Survival Rate(%) of Ecuador in 2003 to that in 2006?
Offer a terse response. 0.93. What is the ratio of the Survival Rate(%) in Burundi in 2003 to that in 2010?
Give a very brief answer. 1.03. What is the ratio of the Survival Rate(%) of Ecuador in 2003 to that in 2010?
Ensure brevity in your answer.  0.83. What is the ratio of the Survival Rate(%) of Japan in 2003 to that in 2010?
Give a very brief answer. 1. What is the ratio of the Survival Rate(%) in Burundi in 2004 to that in 2006?
Offer a terse response. 0.99. What is the ratio of the Survival Rate(%) of Ecuador in 2004 to that in 2006?
Offer a very short reply. 0.93. What is the ratio of the Survival Rate(%) of Korea (Republic) in 2004 to that in 2006?
Offer a terse response. 1.01. What is the ratio of the Survival Rate(%) in Burundi in 2004 to that in 2010?
Ensure brevity in your answer.  1.14. What is the ratio of the Survival Rate(%) in Ecuador in 2004 to that in 2010?
Offer a terse response. 0.83. What is the ratio of the Survival Rate(%) in Japan in 2004 to that in 2010?
Offer a terse response. 1. What is the ratio of the Survival Rate(%) in Burundi in 2006 to that in 2010?
Offer a terse response. 1.15. What is the ratio of the Survival Rate(%) of Ecuador in 2006 to that in 2010?
Offer a very short reply. 0.89. What is the ratio of the Survival Rate(%) of Japan in 2006 to that in 2010?
Offer a terse response. 1. What is the ratio of the Survival Rate(%) of Korea (Republic) in 2006 to that in 2010?
Give a very brief answer. 0.99. What is the difference between the highest and the second highest Survival Rate(%) of Burundi?
Your response must be concise. 0.17. What is the difference between the highest and the second highest Survival Rate(%) in Ecuador?
Provide a succinct answer. 9.8. What is the difference between the highest and the second highest Survival Rate(%) of Japan?
Your answer should be very brief. 0.01. What is the difference between the highest and the second highest Survival Rate(%) of Korea (Republic)?
Provide a succinct answer. 0.47. What is the difference between the highest and the lowest Survival Rate(%) in Burundi?
Your response must be concise. 12.53. What is the difference between the highest and the lowest Survival Rate(%) of Ecuador?
Provide a succinct answer. 17.91. What is the difference between the highest and the lowest Survival Rate(%) in Japan?
Make the answer very short. 0.06. What is the difference between the highest and the lowest Survival Rate(%) in Korea (Republic)?
Your answer should be compact. 1.78. 